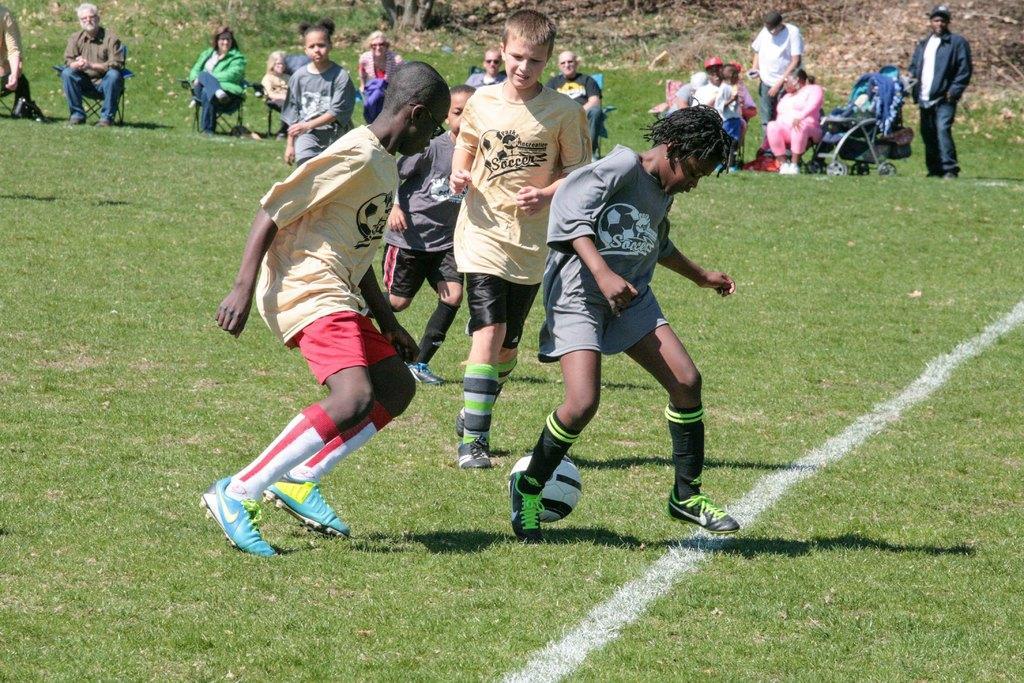Can you describe this image briefly? This is a picture of a playground. In the center of the image there are kids playing football. In the background there are people sitting in chairs. This is a grass court. On top right there is a cart. 